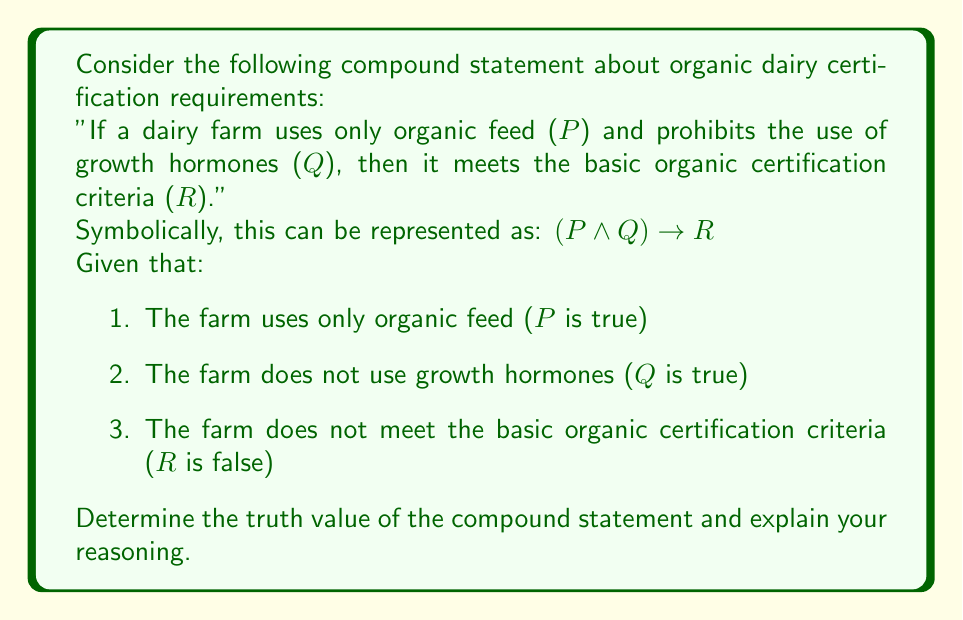Can you solve this math problem? To assess the truth value of the compound statement, we need to evaluate the truth value of each component and then apply the logical connectives.

1. Let's first evaluate the antecedent $(P \land Q)$:
   - P is true (the farm uses only organic feed)
   - Q is true (the farm prohibits the use of growth hormones)
   - $P \land Q$ is true (both conditions are met)

2. Now, let's look at the consequent (R):
   - R is false (the farm does not meet the basic organic certification criteria)

3. The compound statement is an implication: $(P \land Q) \rightarrow R$

4. To evaluate an implication, we use the following truth table:

   | P ∧ Q | R | (P ∧ Q) → R |
   |-------|---|-------------|
   |   T   | T |      T      |
   |   T   | F |      F      |
   |   F   | T |      T      |
   |   F   | F |      T      |

5. In our case, $(P \land Q)$ is true and R is false. This corresponds to the second row of the truth table.

6. Therefore, the truth value of the compound statement $(P \land Q) \rightarrow R$ is false.

This result implies that meeting the conditions of using organic feed and prohibiting growth hormones is not sufficient to guarantee basic organic certification. There may be additional criteria that the farm needs to meet to obtain certification.
Answer: The truth value of the compound statement $(P \land Q) \rightarrow R$ is false. 